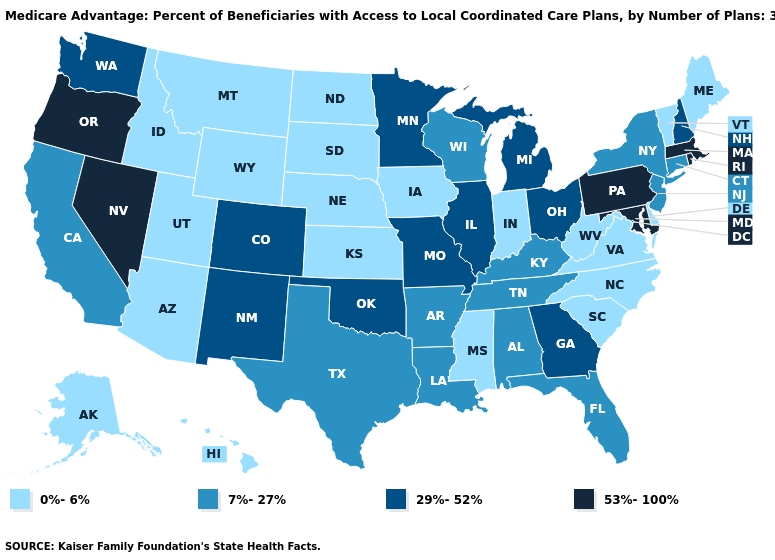What is the value of Rhode Island?
Keep it brief. 53%-100%. Which states have the lowest value in the USA?
Concise answer only. Alaska, Arizona, Delaware, Hawaii, Iowa, Idaho, Indiana, Kansas, Maine, Mississippi, Montana, North Carolina, North Dakota, Nebraska, South Carolina, South Dakota, Utah, Virginia, Vermont, West Virginia, Wyoming. What is the value of Utah?
Be succinct. 0%-6%. What is the value of Kentucky?
Write a very short answer. 7%-27%. What is the value of South Dakota?
Keep it brief. 0%-6%. Name the states that have a value in the range 53%-100%?
Short answer required. Massachusetts, Maryland, Nevada, Oregon, Pennsylvania, Rhode Island. Does the first symbol in the legend represent the smallest category?
Keep it brief. Yes. Name the states that have a value in the range 0%-6%?
Be succinct. Alaska, Arizona, Delaware, Hawaii, Iowa, Idaho, Indiana, Kansas, Maine, Mississippi, Montana, North Carolina, North Dakota, Nebraska, South Carolina, South Dakota, Utah, Virginia, Vermont, West Virginia, Wyoming. What is the value of Kansas?
Quick response, please. 0%-6%. Name the states that have a value in the range 0%-6%?
Give a very brief answer. Alaska, Arizona, Delaware, Hawaii, Iowa, Idaho, Indiana, Kansas, Maine, Mississippi, Montana, North Carolina, North Dakota, Nebraska, South Carolina, South Dakota, Utah, Virginia, Vermont, West Virginia, Wyoming. Name the states that have a value in the range 7%-27%?
Concise answer only. Alabama, Arkansas, California, Connecticut, Florida, Kentucky, Louisiana, New Jersey, New York, Tennessee, Texas, Wisconsin. What is the highest value in states that border Rhode Island?
Keep it brief. 53%-100%. Is the legend a continuous bar?
Answer briefly. No. What is the value of Arizona?
Be succinct. 0%-6%. What is the value of New Jersey?
Answer briefly. 7%-27%. 